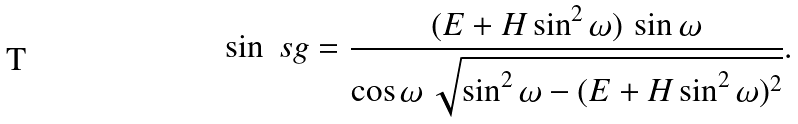Convert formula to latex. <formula><loc_0><loc_0><loc_500><loc_500>\sin \ s g = \frac { ( E + H \sin ^ { 2 } \omega ) \, \sin \omega } { \cos \omega \, \sqrt { \sin ^ { 2 } \omega - ( E + H \sin ^ { 2 } \omega ) ^ { 2 } } } .</formula> 